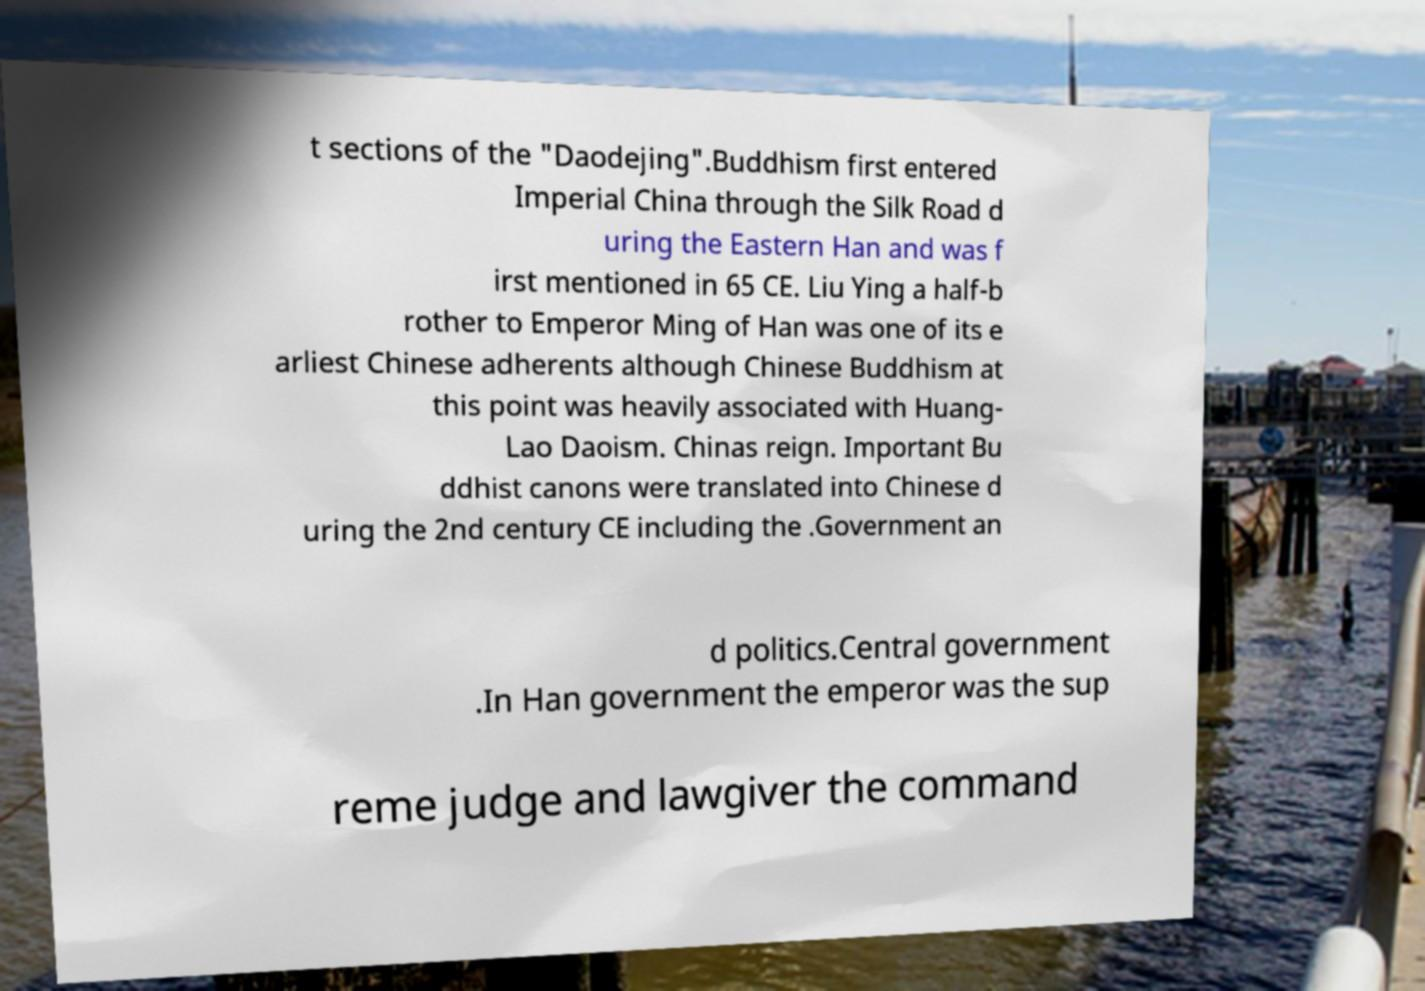What messages or text are displayed in this image? I need them in a readable, typed format. t sections of the "Daodejing".Buddhism first entered Imperial China through the Silk Road d uring the Eastern Han and was f irst mentioned in 65 CE. Liu Ying a half-b rother to Emperor Ming of Han was one of its e arliest Chinese adherents although Chinese Buddhism at this point was heavily associated with Huang- Lao Daoism. Chinas reign. Important Bu ddhist canons were translated into Chinese d uring the 2nd century CE including the .Government an d politics.Central government .In Han government the emperor was the sup reme judge and lawgiver the command 